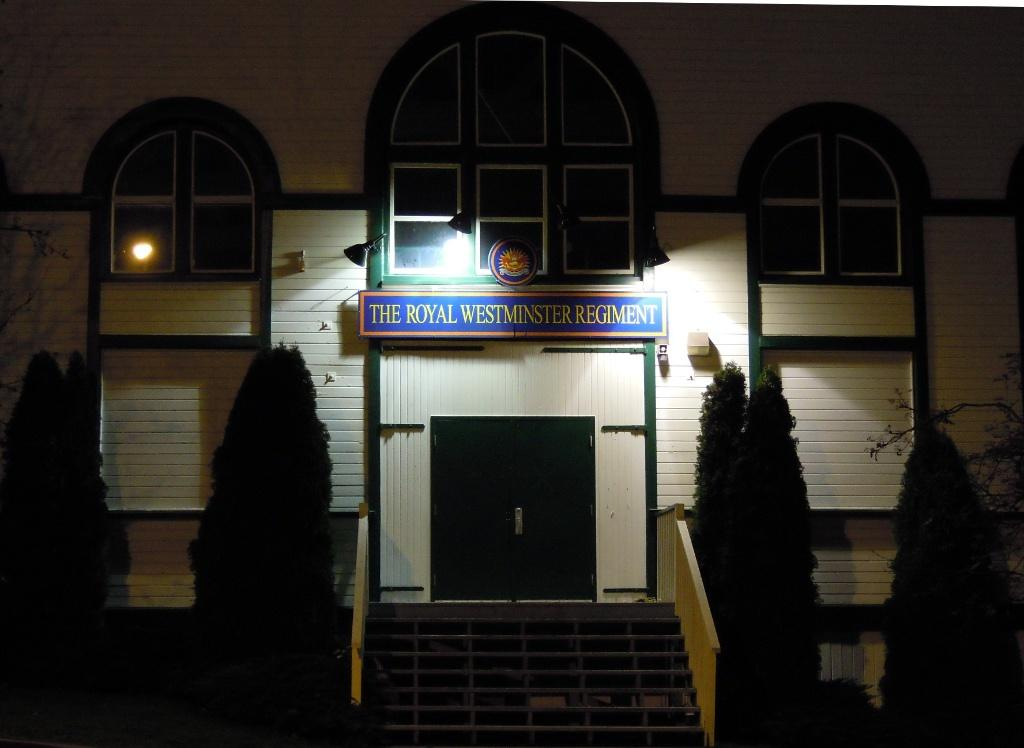What type of vegetation can be seen in the image? There are trees in the image. What architectural feature is present in the image? There are stairs and a railing visible in the image. What type of structure is in the image? There is a building in the image. What color is the board present in the image? The board is blue in color. What source of illumination is visible in the image? There is a light in the image. What part of the building can be seen in the image? The windows of the building are visible. What type of flesh can be seen hanging from the trees in the image? There is no flesh present in the image; it features trees, stairs, a railing, a building, a blue board, a light, and visible windows. What purpose does the bucket serve in the image? There is no bucket present in the image. 